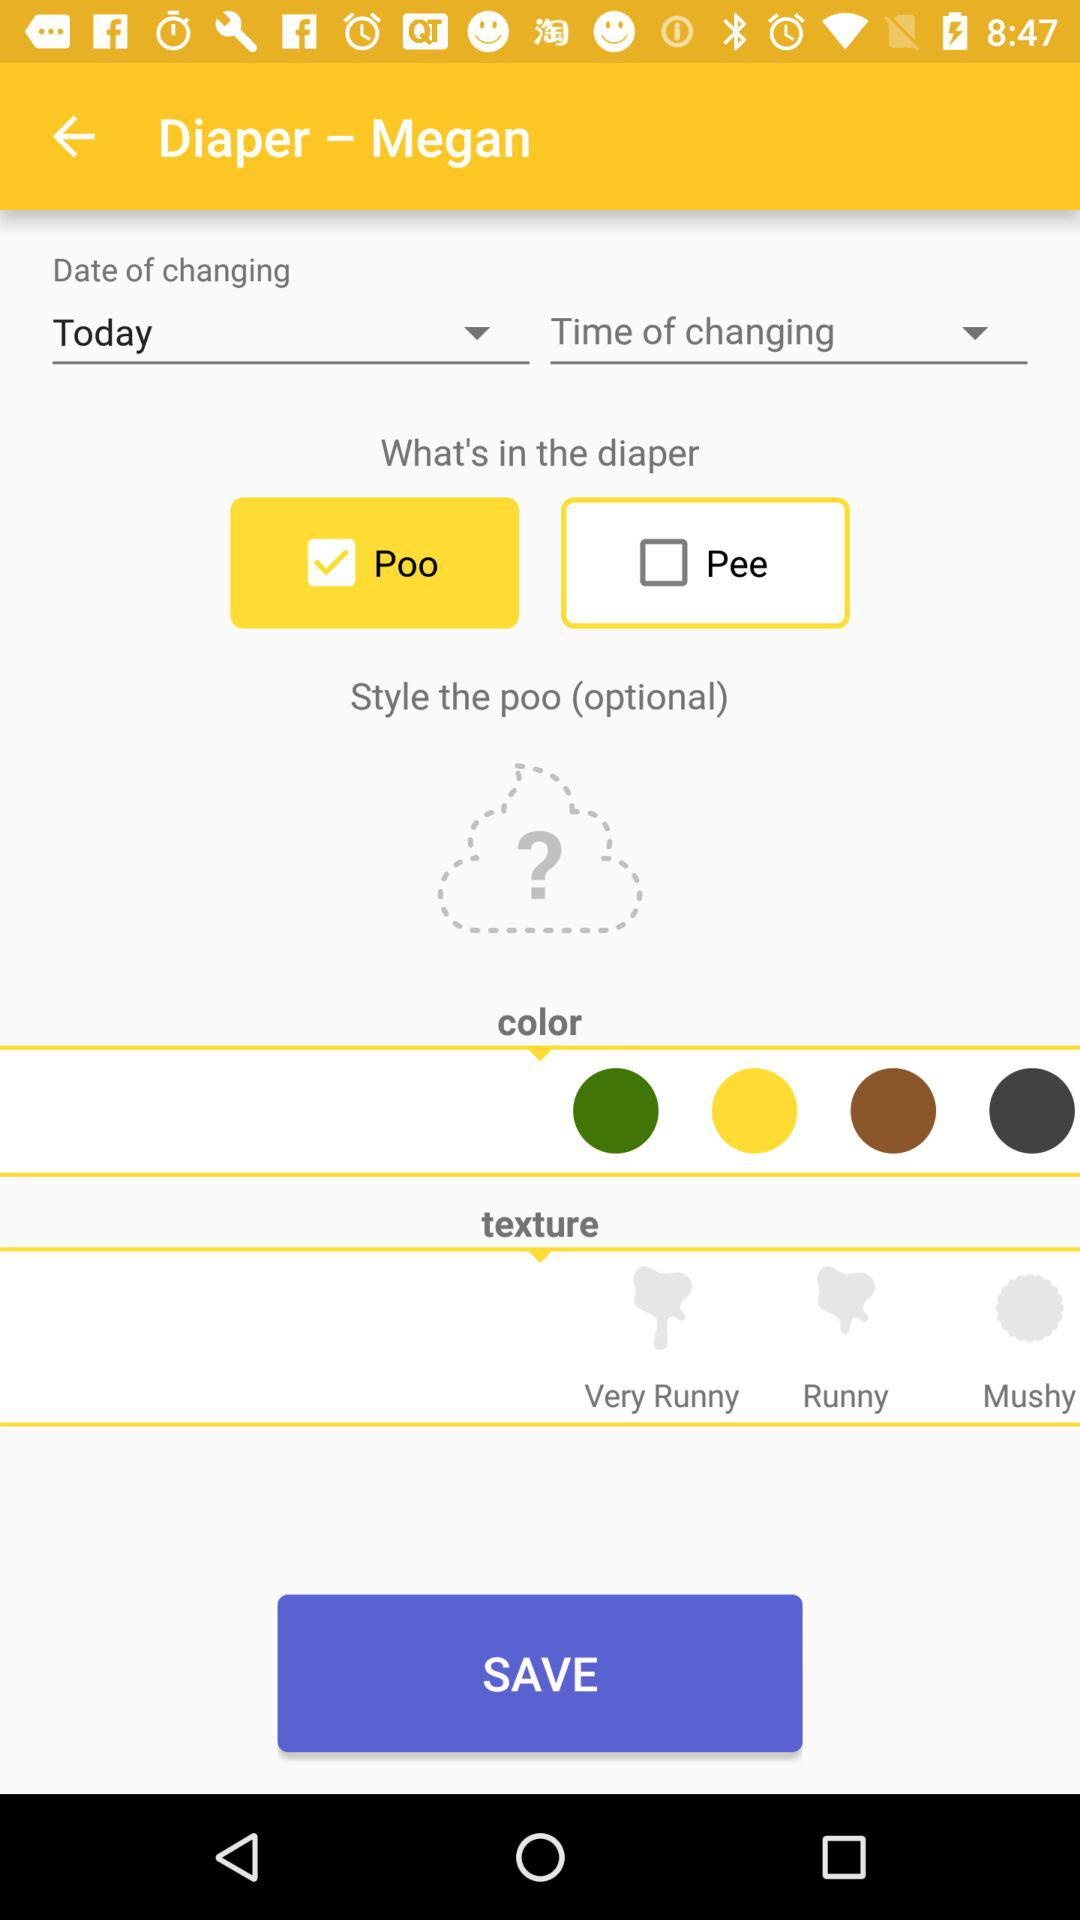What is the selected option for "What's in the diaper"? The selected option is "Poo". 